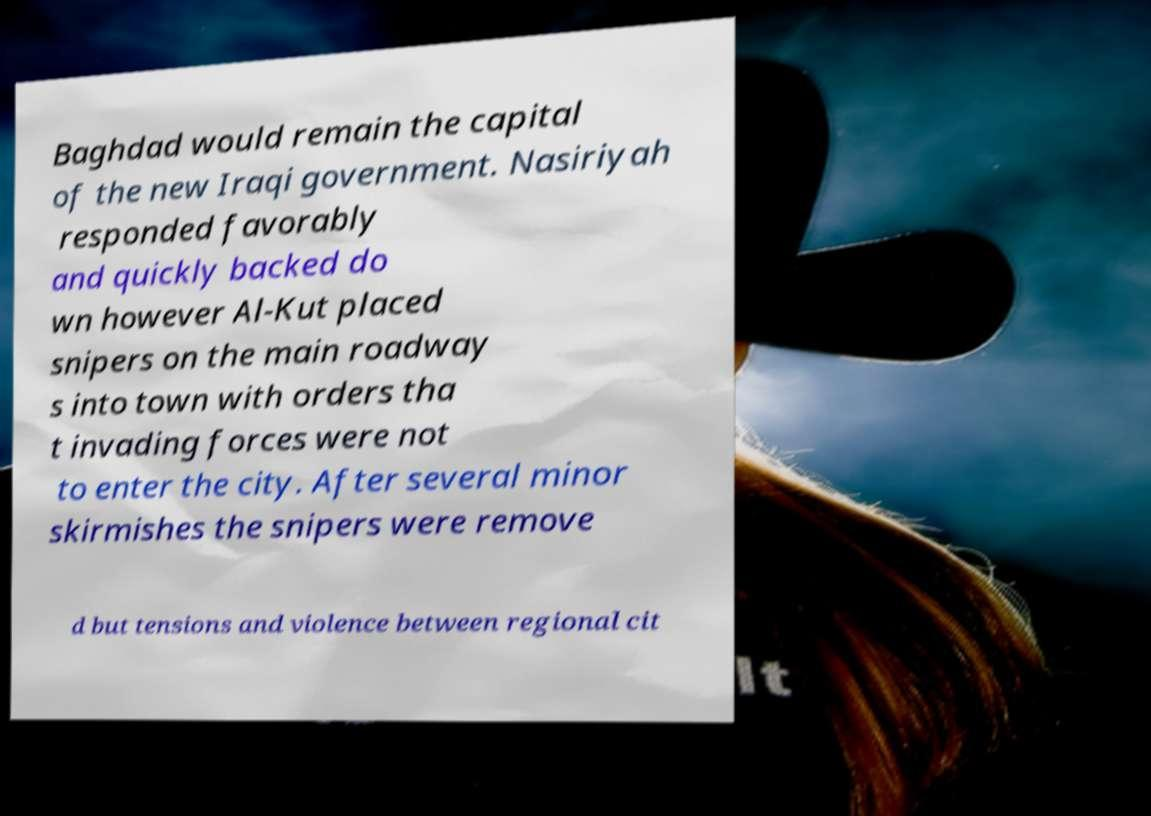What messages or text are displayed in this image? I need them in a readable, typed format. Baghdad would remain the capital of the new Iraqi government. Nasiriyah responded favorably and quickly backed do wn however Al-Kut placed snipers on the main roadway s into town with orders tha t invading forces were not to enter the city. After several minor skirmishes the snipers were remove d but tensions and violence between regional cit 